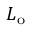Convert formula to latex. <formula><loc_0><loc_0><loc_500><loc_500>L _ { o }</formula> 